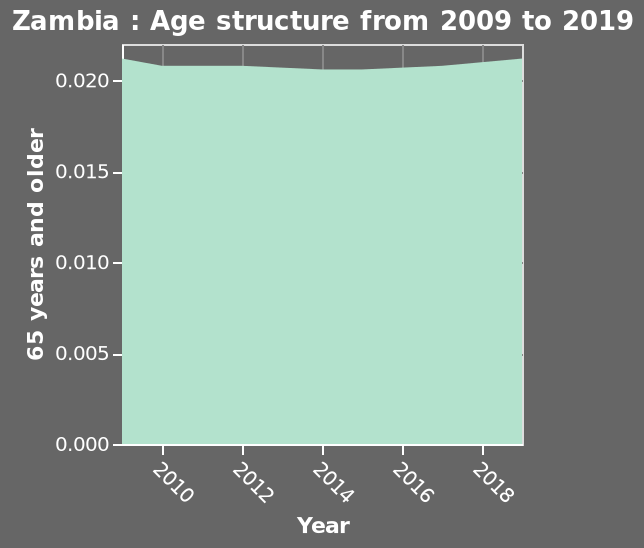<image>
What does the x-axis measure in the age structure graph of Zambia?  The x-axis in the age structure graph of Zambia measures the years from 2009 to 2019. What is the trend in the population of individuals aged 65 years and older in Zambia from 2009 to 2019? The trend in the population of individuals aged 65 years and older in Zambia from 2009 to 2019 can be observed by analyzing the area graph. Did the age composition of Zambia's population change significantly in the given period? No, there has been little change in the age composition of Zambia's population during the given period. Has there been any notable fluctuation in the age distribution in Zambia within the stated period?  No, there has been little fluctuation in the age distribution in Zambia within the stated period. Does the x-axis in the age structure graph of Zambia measure the years from 2019 to 2009? No. The x-axis in the age structure graph of Zambia measures the years from 2009 to 2019. 